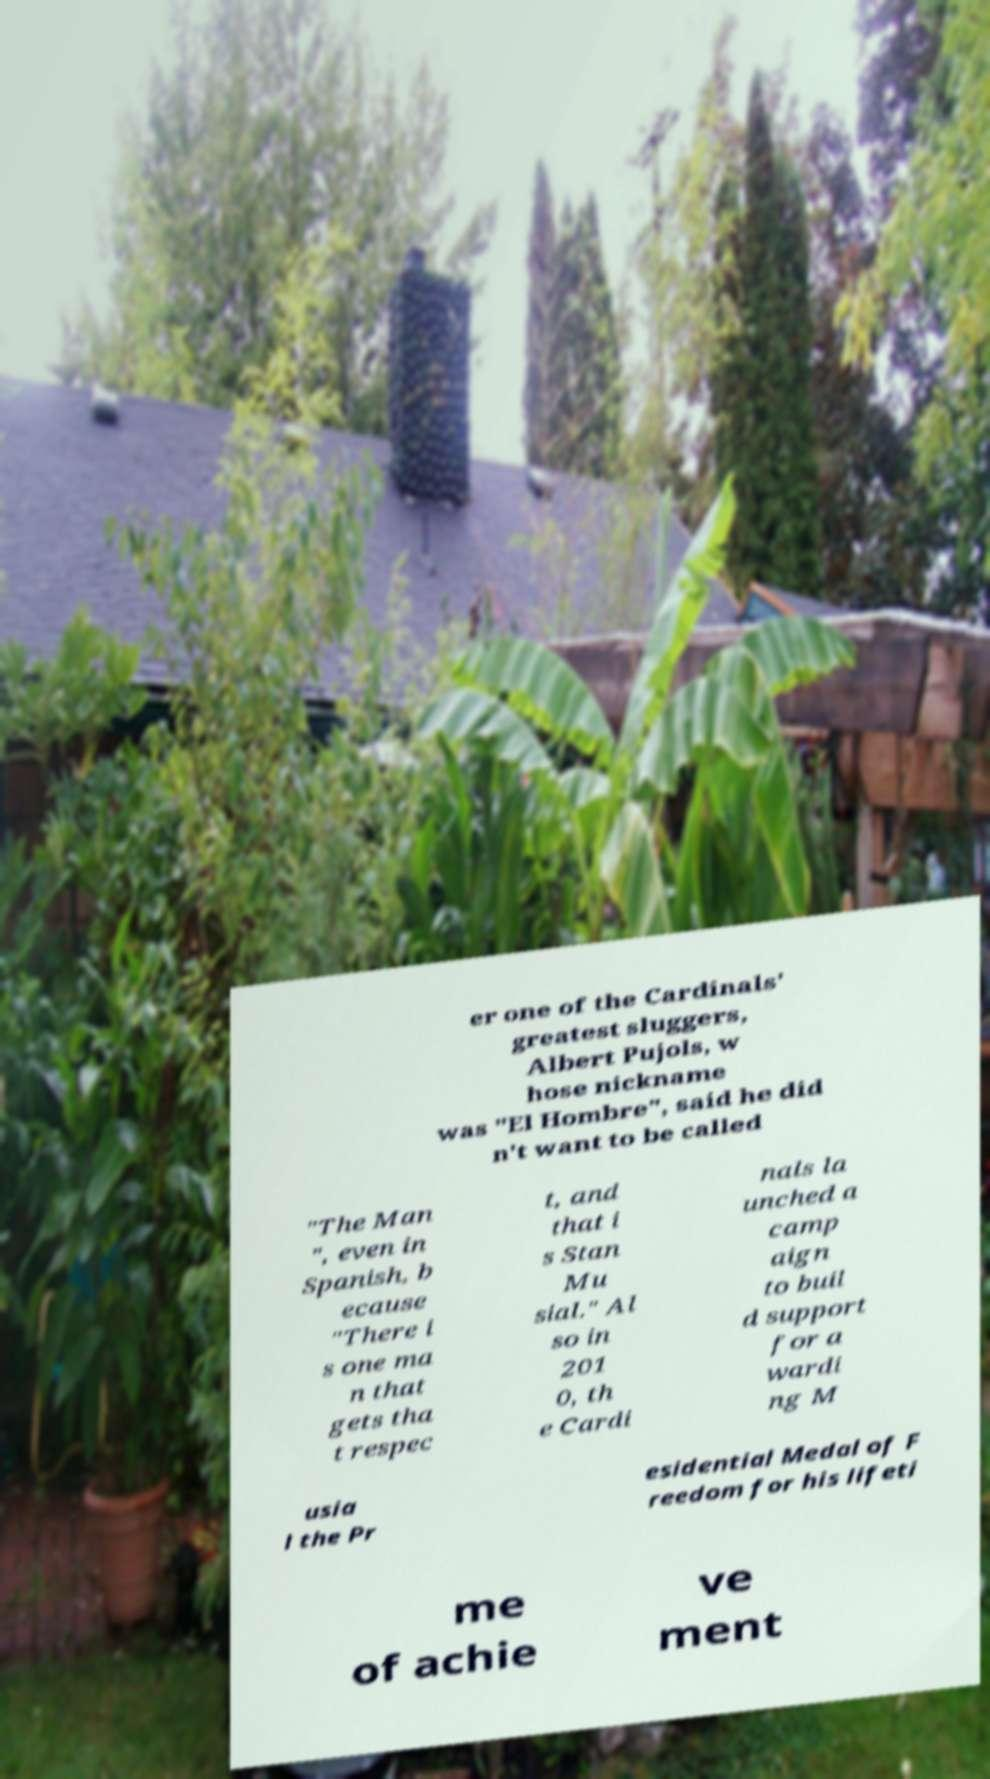Please identify and transcribe the text found in this image. er one of the Cardinals' greatest sluggers, Albert Pujols, w hose nickname was "El Hombre", said he did n't want to be called "The Man ", even in Spanish, b ecause "There i s one ma n that gets tha t respec t, and that i s Stan Mu sial." Al so in 201 0, th e Cardi nals la unched a camp aign to buil d support for a wardi ng M usia l the Pr esidential Medal of F reedom for his lifeti me of achie ve ment 